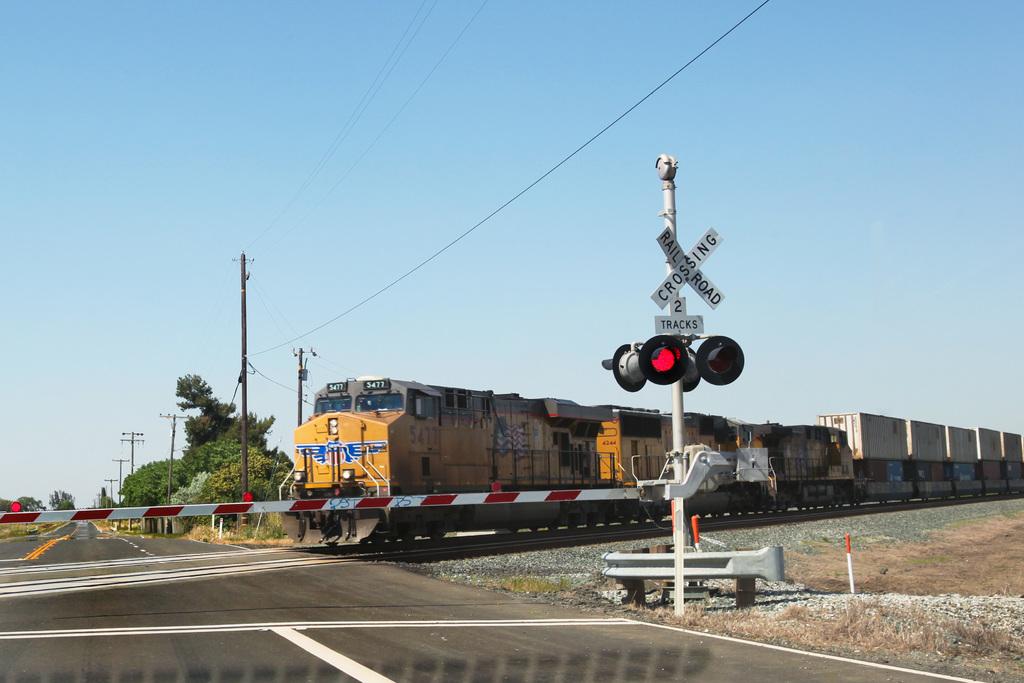Is there a railroad crossing sign shown?
Provide a short and direct response. Yes. 